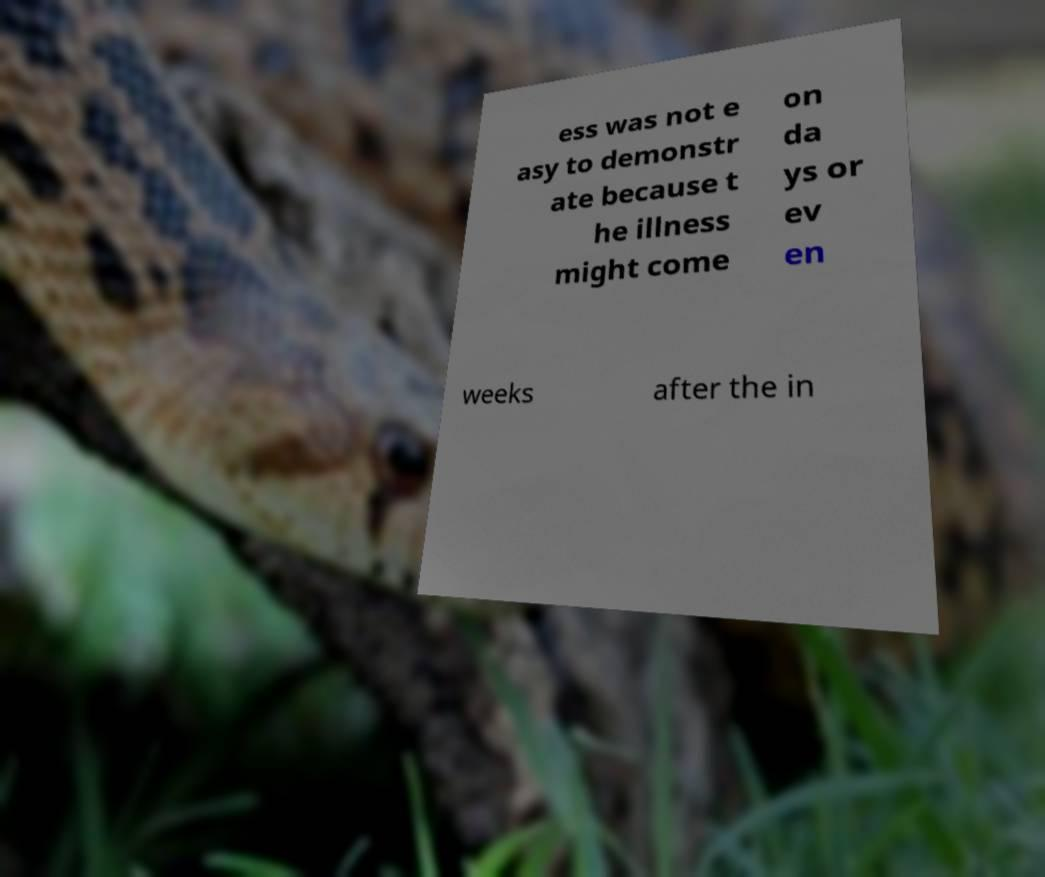Can you accurately transcribe the text from the provided image for me? ess was not e asy to demonstr ate because t he illness might come on da ys or ev en weeks after the in 